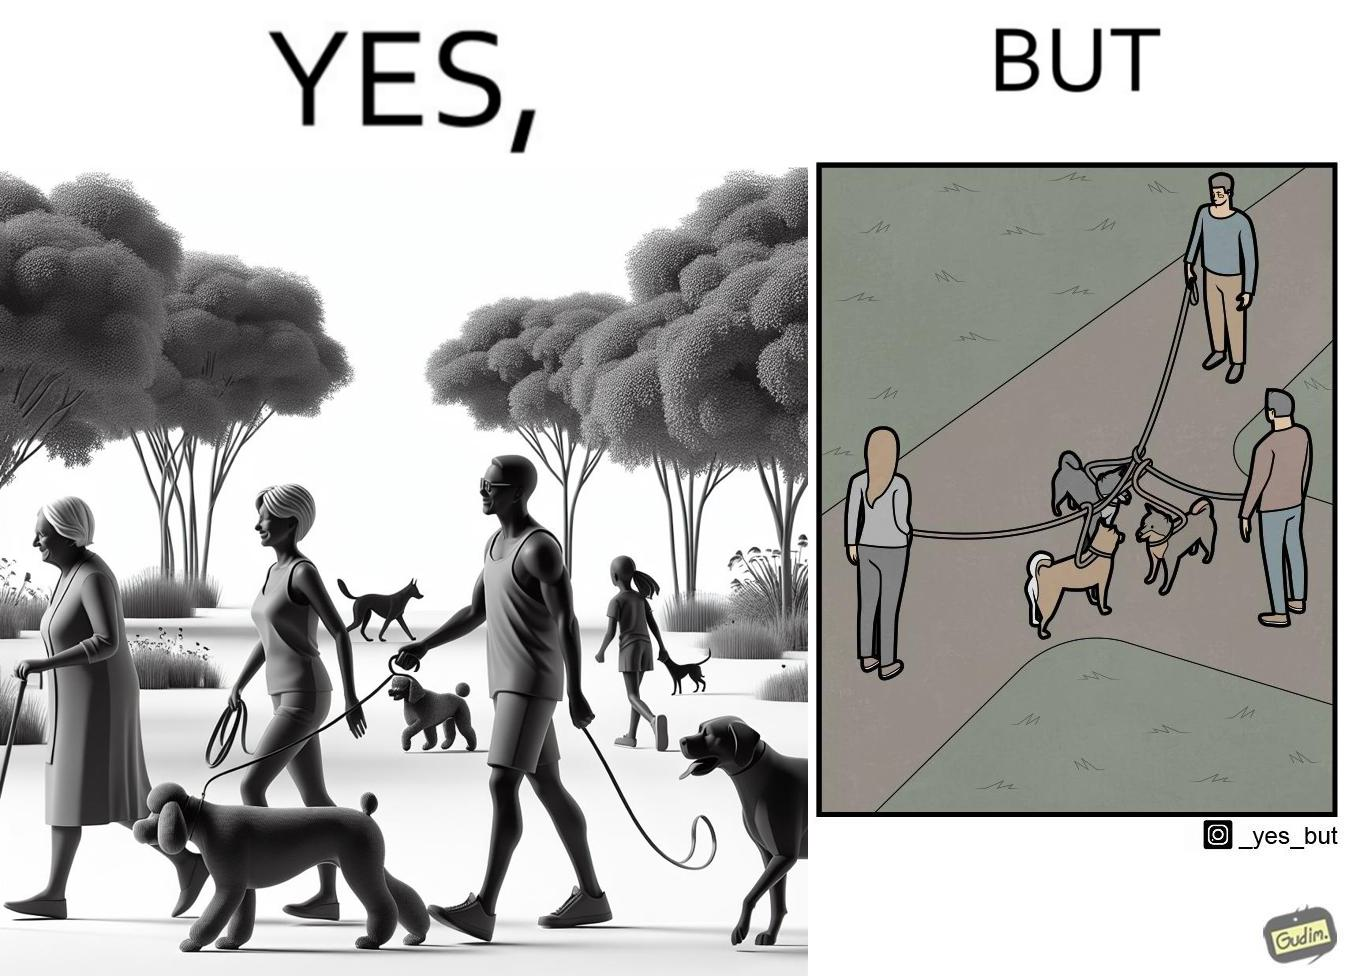What is shown in the left half versus the right half of this image? In the left part of the image: three different dog owners with their dog walking in some park In the right part of the image: three different dog owners with their dog walking in some park with their dogs mingled 